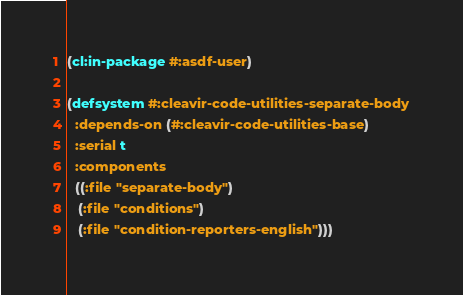<code> <loc_0><loc_0><loc_500><loc_500><_Lisp_>(cl:in-package #:asdf-user)

(defsystem #:cleavir-code-utilities-separate-body
  :depends-on (#:cleavir-code-utilities-base)
  :serial t
  :components
  ((:file "separate-body")
   (:file "conditions")
   (:file "condition-reporters-english")))
</code> 